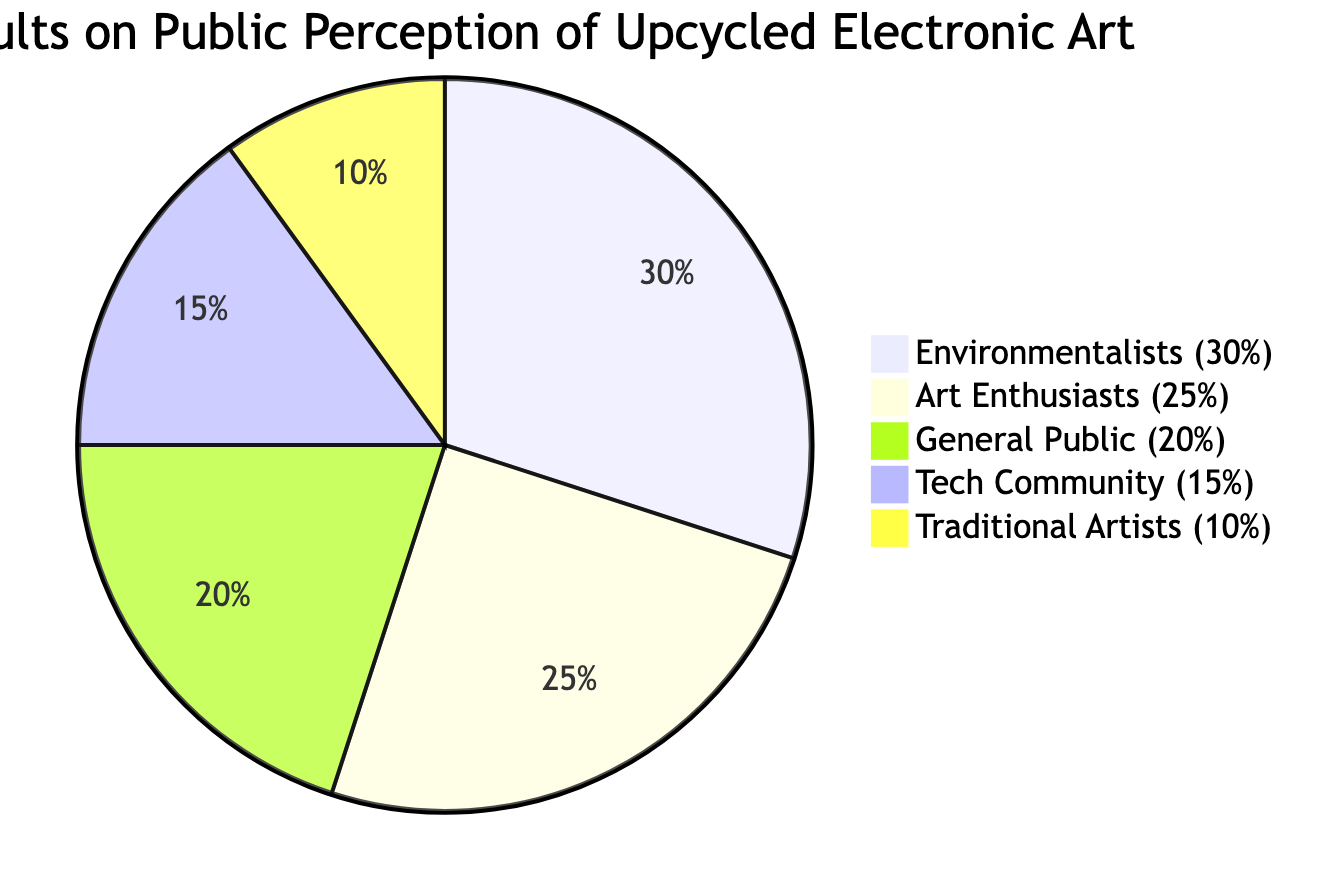What percentage of the surveyed group are environmentalists? The pie chart directly indicates that environmentalists represent 30% of the total surveyed group. Thus, the value is explicitly stated in the diagram.
Answer: 30% Which group has the least representation in the survey? By comparing all the percentages given in the pie chart, traditional artists have the lowest representation at 10%, which is less than all other groups.
Answer: Traditional Artists What is the combined percentage of art enthusiasts and the general public? To find this combined percentage, you add the values of art enthusiasts (25%) and the general public (20%), resulting in 25 + 20, which equals 45%.
Answer: 45% How many distinct groups are represented in the survey results? The pie chart lists five different groups: art enthusiasts, environmentalists, the general public, the tech community, and traditional artists. By counting these groups, we find there are five.
Answer: 5 What percentage of the tech community views upcycled electronic art positively? The pie chart shows that the tech community represents 15% of the surveyed opinions, which indicates their viewpoint regarding upcycled electronic art.
Answer: 15% What is the difference in percentage between art enthusiasts and tech community opinions? To find the difference, we subtract the tech community's percentage (15%) from the art enthusiasts' percentage (25%), resulting in 25 - 15 = 10.
Answer: 10 What percentage of surveyed individuals does the general public account for? The pie chart explicitly provides the percentage for the general public, indicating that they make up 20% of those surveyed.
Answer: 20% What is the total percentage accounted for by the environmentalists and traditional artists combined? To find the total for these two groups, sum their percentages: environmentalists (30%) and traditional artists (10%), giving us 30 + 10 = 40%.
Answer: 40% 